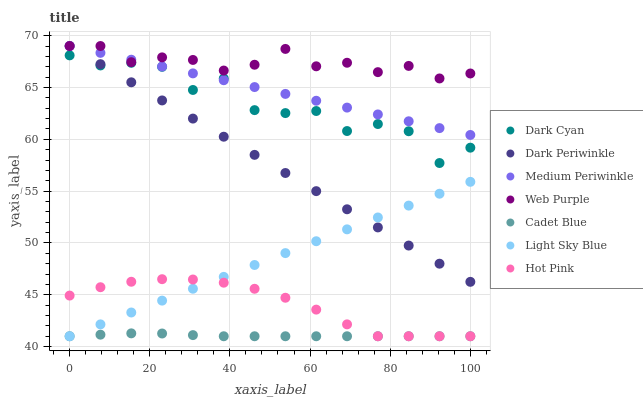Does Cadet Blue have the minimum area under the curve?
Answer yes or no. Yes. Does Web Purple have the maximum area under the curve?
Answer yes or no. Yes. Does Hot Pink have the minimum area under the curve?
Answer yes or no. No. Does Hot Pink have the maximum area under the curve?
Answer yes or no. No. Is Light Sky Blue the smoothest?
Answer yes or no. Yes. Is Dark Cyan the roughest?
Answer yes or no. Yes. Is Hot Pink the smoothest?
Answer yes or no. No. Is Hot Pink the roughest?
Answer yes or no. No. Does Cadet Blue have the lowest value?
Answer yes or no. Yes. Does Medium Periwinkle have the lowest value?
Answer yes or no. No. Does Dark Periwinkle have the highest value?
Answer yes or no. Yes. Does Hot Pink have the highest value?
Answer yes or no. No. Is Hot Pink less than Dark Cyan?
Answer yes or no. Yes. Is Web Purple greater than Hot Pink?
Answer yes or no. Yes. Does Dark Periwinkle intersect Light Sky Blue?
Answer yes or no. Yes. Is Dark Periwinkle less than Light Sky Blue?
Answer yes or no. No. Is Dark Periwinkle greater than Light Sky Blue?
Answer yes or no. No. Does Hot Pink intersect Dark Cyan?
Answer yes or no. No. 